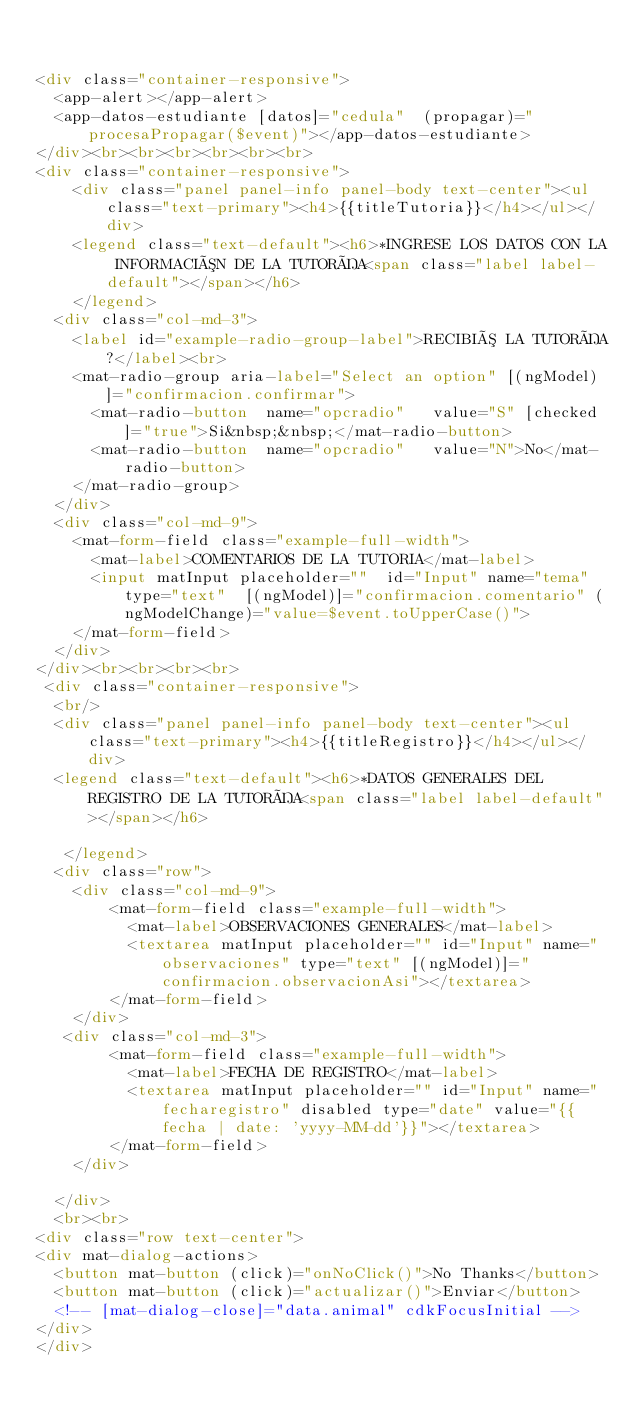<code> <loc_0><loc_0><loc_500><loc_500><_HTML_>

<div class="container-responsive">
  <app-alert></app-alert>
  <app-datos-estudiante [datos]="cedula"  (propagar)="procesaPropagar($event)"></app-datos-estudiante>
</div><br><br><br><br><br><br>
<div class="container-responsive">
    <div class="panel panel-info panel-body text-center"><ul class="text-primary"><h4>{{titleTutoria}}</h4></ul></div>
    <legend class="text-default"><h6>*INGRESE LOS DATOS CON LA INFORMACIÓN DE LA TUTORÍA<span class="label label-default"></span></h6>  
    </legend>  
  <div class="col-md-3">
    <label id="example-radio-group-label">RECIBIÓ LA TUTORÍA?</label><br>
    <mat-radio-group aria-label="Select an option" [(ngModel)]="confirmacion.confirmar">
      <mat-radio-button  name="opcradio"   value="S" [checked]="true">Si&nbsp;&nbsp;</mat-radio-button>
      <mat-radio-button  name="opcradio"   value="N">No</mat-radio-button>
    </mat-radio-group>  
  </div>
  <div class="col-md-9">
    <mat-form-field class="example-full-width">
      <mat-label>COMENTARIOS DE LA TUTORIA</mat-label>
      <input matInput placeholder=""  id="Input" name="tema" type="text"  [(ngModel)]="confirmacion.comentario" (ngModelChange)="value=$event.toUpperCase()">
    </mat-form-field> 
  </div>
</div><br><br><br><br>
 <div class="container-responsive">
  <br/>
  <div class="panel panel-info panel-body text-center"><ul class="text-primary"><h4>{{titleRegistro}}</h4></ul></div>
  <legend class="text-default"><h6>*DATOS GENERALES DEL REGISTRO DE LA TUTORÍA<span class="label label-default"></span></h6>
    
   </legend>
  <div class="row">
    <div class="col-md-9">
        <mat-form-field class="example-full-width">
          <mat-label>OBSERVACIONES GENERALES</mat-label>
          <textarea matInput placeholder="" id="Input" name="observaciones" type="text" [(ngModel)]="confirmacion.observacionAsi"></textarea>
        </mat-form-field>
    </div>
   <div class="col-md-3">
        <mat-form-field class="example-full-width">
          <mat-label>FECHA DE REGISTRO</mat-label>
          <textarea matInput placeholder="" id="Input" name="fecharegistro" disabled type="date" value="{{fecha | date: 'yyyy-MM-dd'}}"></textarea>
        </mat-form-field>
    </div>

  </div>
  <br><br>
<div class="row text-center">
<div mat-dialog-actions>
  <button mat-button (click)="onNoClick()">No Thanks</button>
  <button mat-button (click)="actualizar()">Enviar</button>
  <!-- [mat-dialog-close]="data.animal" cdkFocusInitial -->
</div>
</div>





</code> 